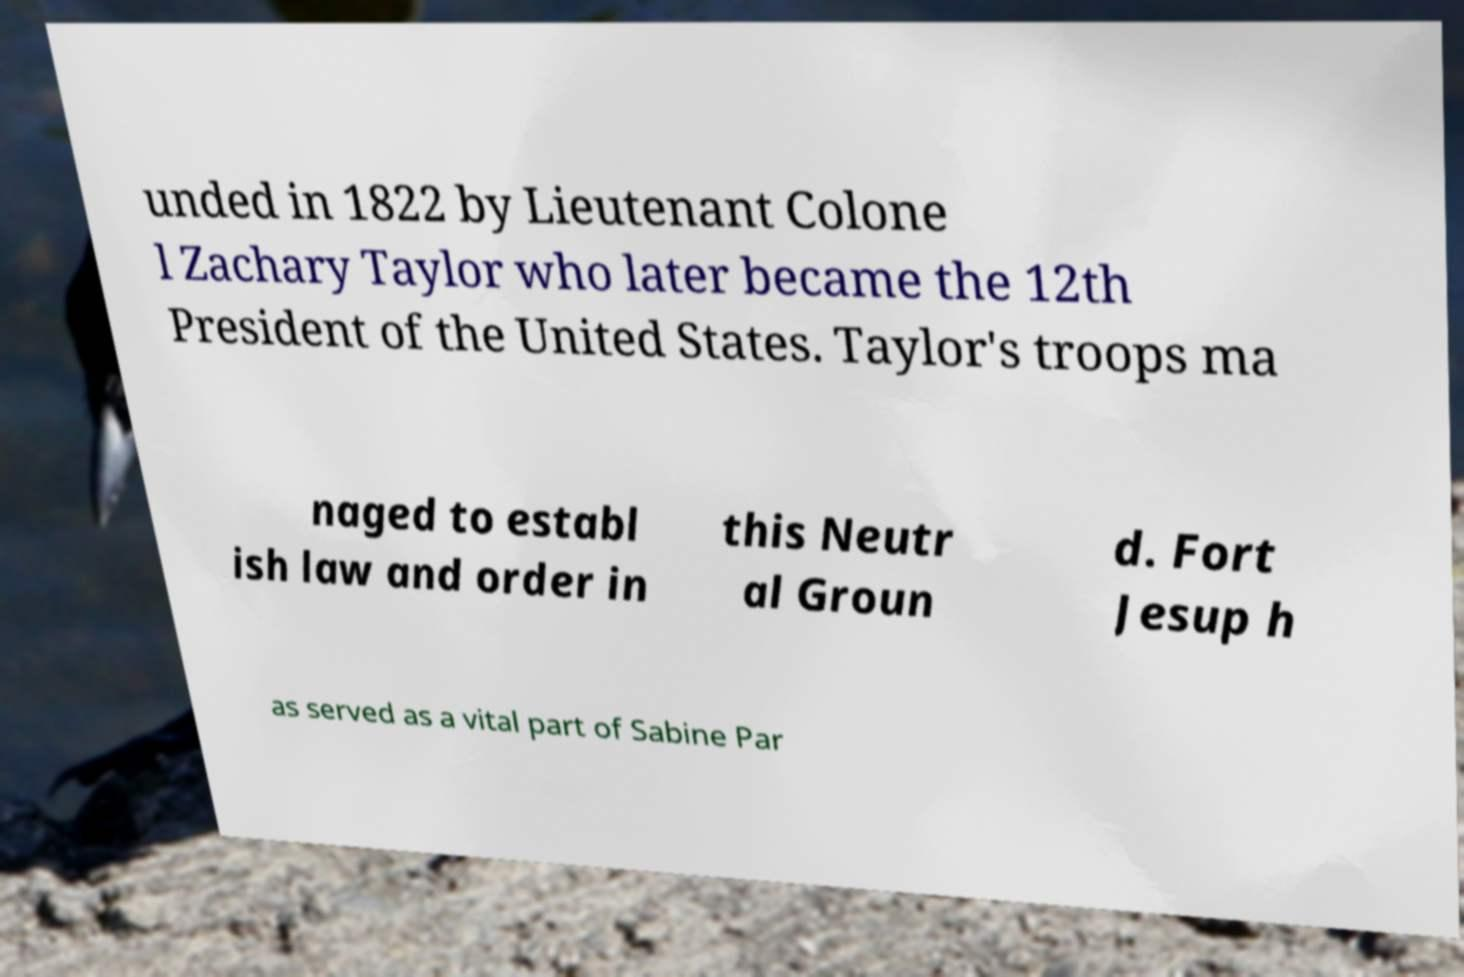What messages or text are displayed in this image? I need them in a readable, typed format. unded in 1822 by Lieutenant Colone l Zachary Taylor who later became the 12th President of the United States. Taylor's troops ma naged to establ ish law and order in this Neutr al Groun d. Fort Jesup h as served as a vital part of Sabine Par 